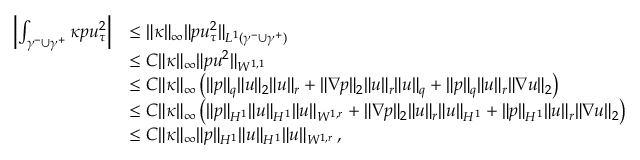Convert formula to latex. <formula><loc_0><loc_0><loc_500><loc_500>\begin{array} { r l } { \left | \int _ { \gamma ^ { - } \cup \gamma ^ { + } } \kappa p u _ { \tau } ^ { 2 } \right | } & { \leq \| \kappa \| _ { \infty } \| p u _ { \tau } ^ { 2 } \| _ { L ^ { 1 } ( \gamma ^ { - } \cup \gamma ^ { + } ) } } \\ & { \leq C \| \kappa \| _ { \infty } \| p u ^ { 2 } \| _ { W ^ { 1 , 1 } } } \\ & { \leq C \| \kappa \| _ { \infty } \left ( \| p \| _ { q } \| u \| _ { 2 } \| u \| _ { r } + \| \nabla p \| _ { 2 } \| u \| _ { r } \| u \| _ { q } + \| p \| _ { q } \| u \| _ { r } \| \nabla u \| _ { 2 } \right ) } \\ & { \leq C \| \kappa \| _ { \infty } \left ( \| p \| _ { H ^ { 1 } } \| u \| _ { H ^ { 1 } } \| u \| _ { W ^ { 1 , r } } + \| \nabla p \| _ { 2 } \| u \| _ { r } \| u \| _ { H ^ { 1 } } + \| p \| _ { H ^ { 1 } } \| u \| _ { r } \| \nabla u \| _ { 2 } \right ) } \\ & { \leq C \| \kappa \| _ { \infty } \| p \| _ { H ^ { 1 } } \| u \| _ { H ^ { 1 } } \| u \| _ { W ^ { 1 , r } } \, , } \end{array}</formula> 